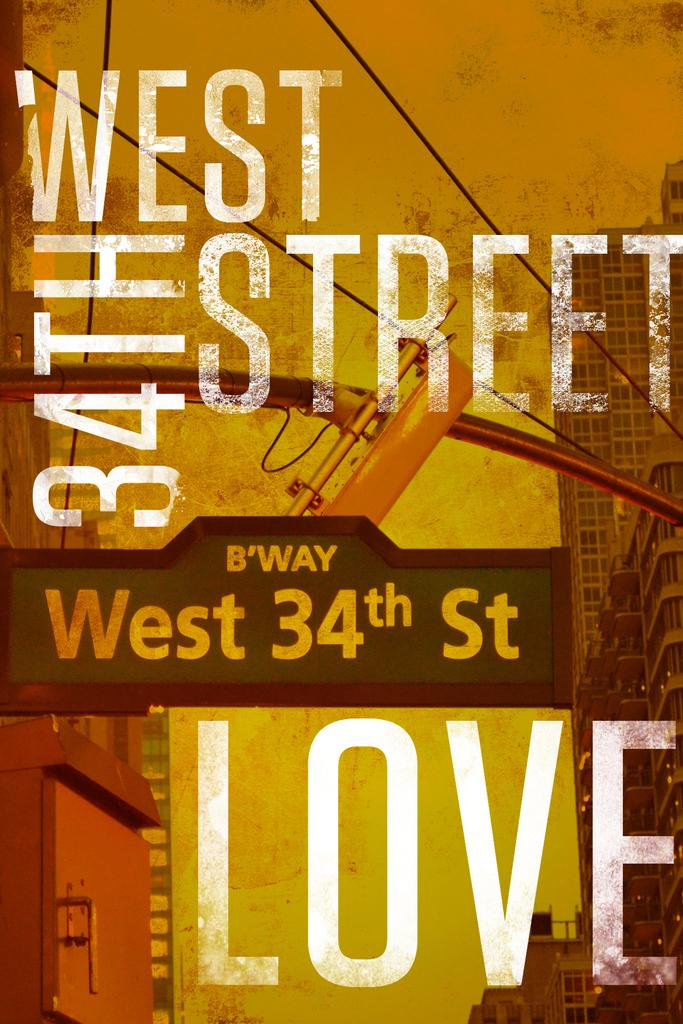Provide a one-sentence caption for the provided image. A poster with West 34th street on the front. 